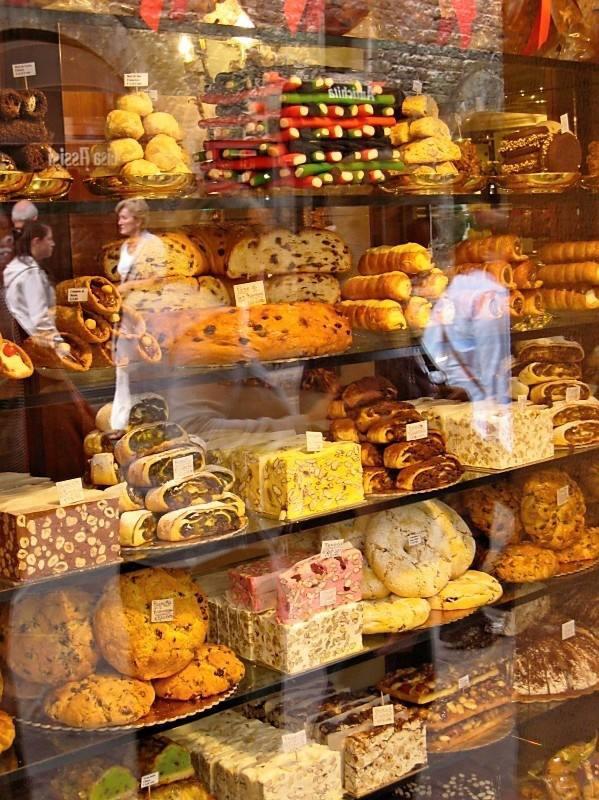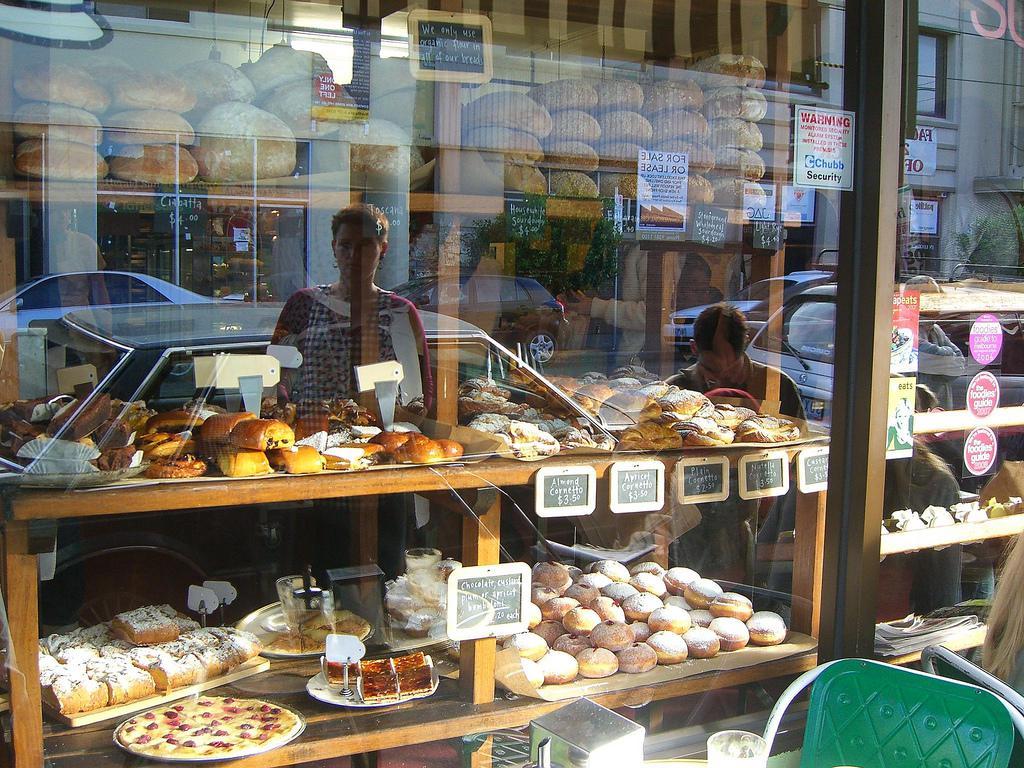The first image is the image on the left, the second image is the image on the right. For the images displayed, is the sentence "Two bakery windows show the reflection of at least one person." factually correct? Answer yes or no. Yes. The first image is the image on the left, the second image is the image on the right. Given the left and right images, does the statement "The left image shows tiered shelves of baked goods behind glass, with white cards above some items facing the glass." hold true? Answer yes or no. Yes. 